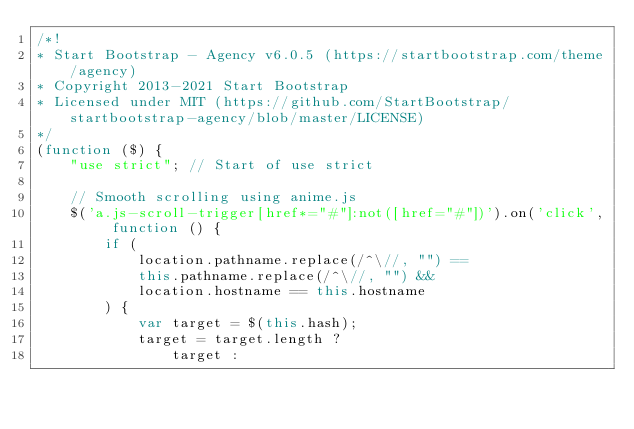<code> <loc_0><loc_0><loc_500><loc_500><_JavaScript_>/*!
* Start Bootstrap - Agency v6.0.5 (https://startbootstrap.com/theme/agency)
* Copyright 2013-2021 Start Bootstrap
* Licensed under MIT (https://github.com/StartBootstrap/startbootstrap-agency/blob/master/LICENSE)
*/
(function ($) {
    "use strict"; // Start of use strict

    // Smooth scrolling using anime.js
    $('a.js-scroll-trigger[href*="#"]:not([href="#"])').on('click', function () {
        if (
            location.pathname.replace(/^\//, "") ==
            this.pathname.replace(/^\//, "") &&
            location.hostname == this.hostname
        ) {
            var target = $(this.hash);
            target = target.length ?
                target :</code> 